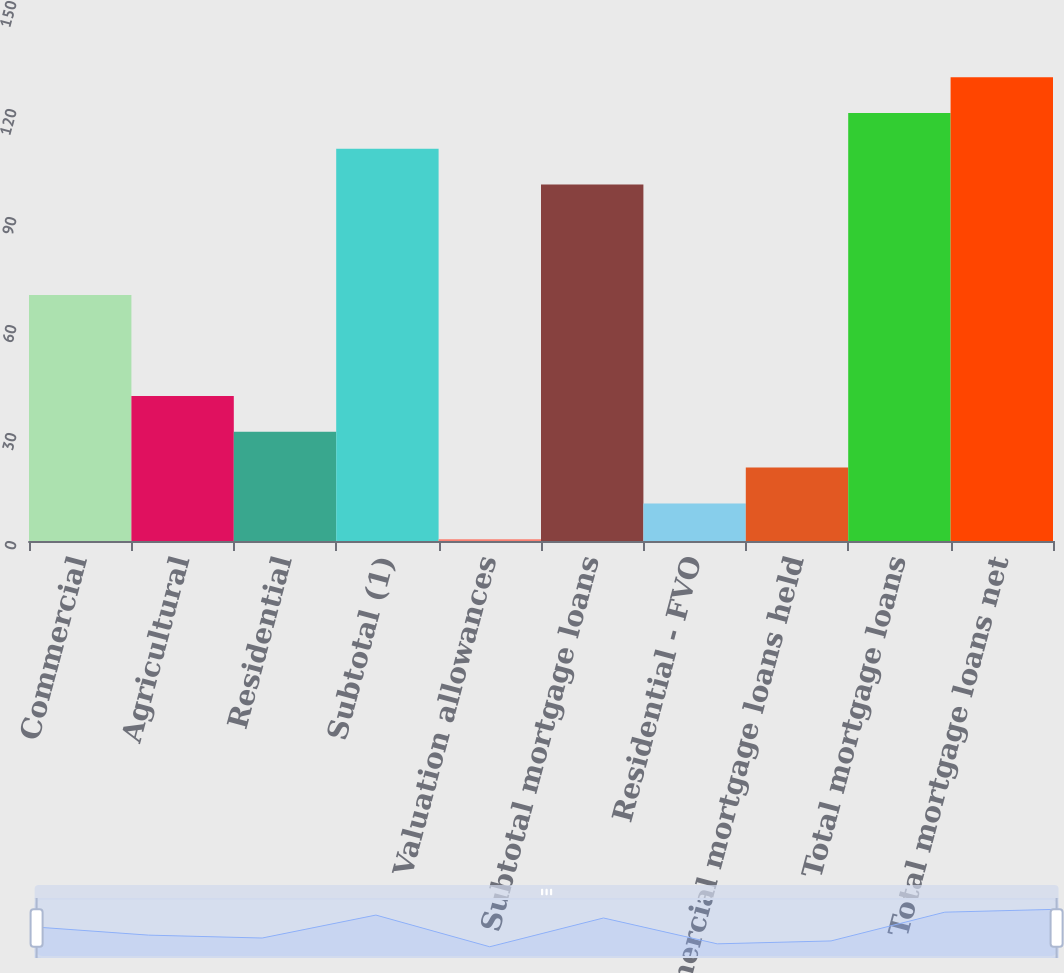<chart> <loc_0><loc_0><loc_500><loc_500><bar_chart><fcel>Commercial<fcel>Agricultural<fcel>Residential<fcel>Subtotal (1)<fcel>Valuation allowances<fcel>Subtotal mortgage loans<fcel>Residential - FVO<fcel>Commercial mortgage loans held<fcel>Total mortgage loans<fcel>Total mortgage loans net<nl><fcel>68.3<fcel>40.3<fcel>30.35<fcel>108.95<fcel>0.5<fcel>99<fcel>10.45<fcel>20.4<fcel>118.9<fcel>128.85<nl></chart> 